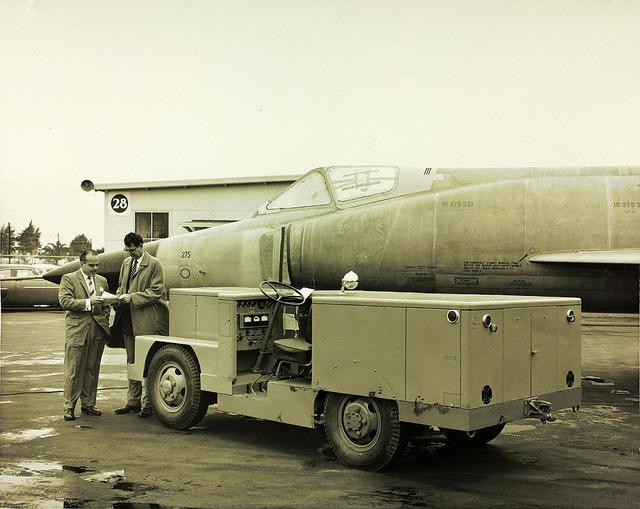How many men are there?
Write a very short answer. 2. Is this an old picture?
Short answer required. Yes. What are the mend holding?
Give a very brief answer. Papers. 